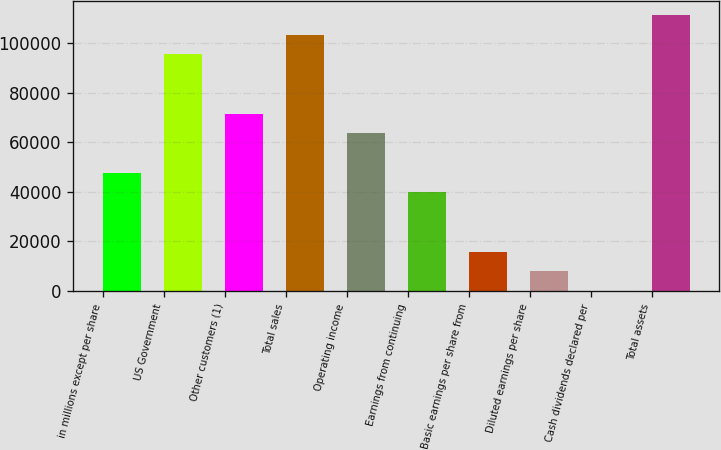<chart> <loc_0><loc_0><loc_500><loc_500><bar_chart><fcel>in millions except per share<fcel>US Government<fcel>Other customers (1)<fcel>Total sales<fcel>Operating income<fcel>Earnings from continuing<fcel>Basic earnings per share from<fcel>Diluted earnings per share<fcel>Cash dividends declared per<fcel>Total assets<nl><fcel>47760.8<fcel>95519.7<fcel>71640.2<fcel>103480<fcel>63680.4<fcel>39800.9<fcel>15921.5<fcel>7961.66<fcel>1.84<fcel>111439<nl></chart> 